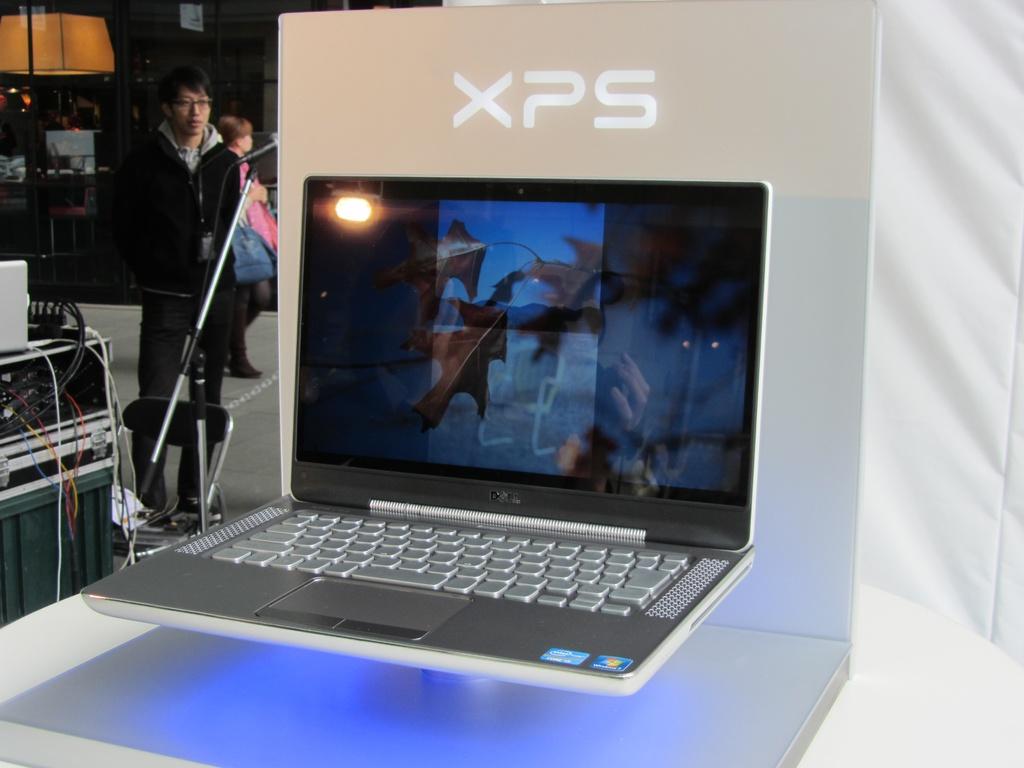What brand is the laptop?
Offer a terse response. Xps. What color is the name of the brand of the laptop?
Ensure brevity in your answer.  White. 